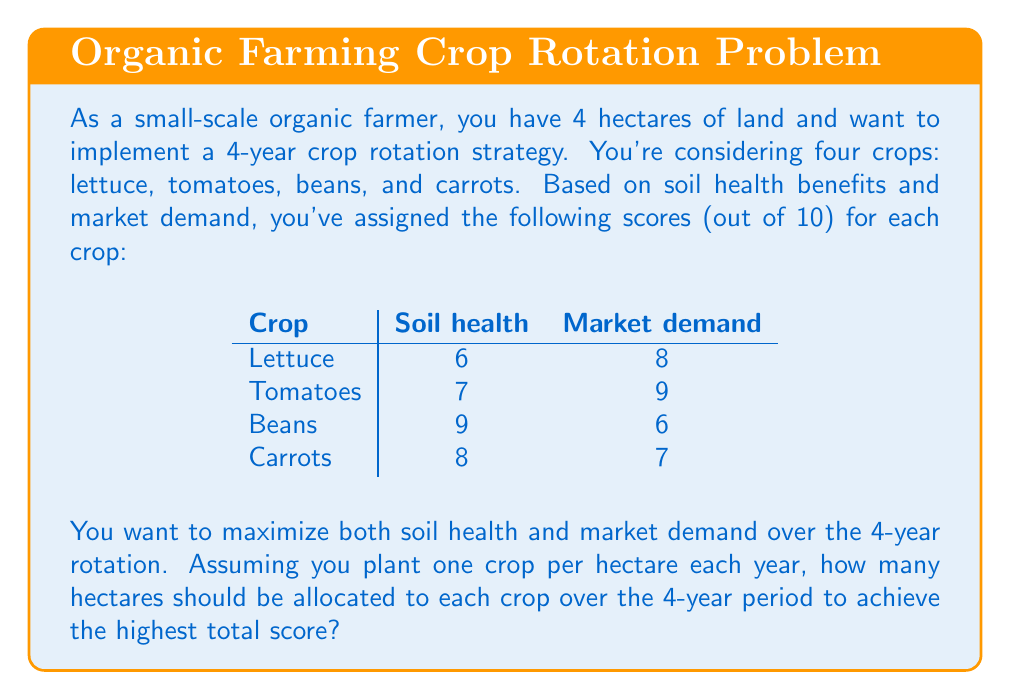Teach me how to tackle this problem. To solve this problem, we need to use integer programming, a branch of decision theory. Let's approach this step-by-step:

1) Define variables:
   Let $x_1, x_2, x_3, x_4$ represent the number of hectares allocated to lettuce, tomatoes, beans, and carrots respectively over the 4-year period.

2) Set up the objective function:
   We want to maximize the total score, which is the sum of soil health and market demand scores for each crop, multiplied by the number of hectares allocated to that crop:

   $$\text{Max } Z = (6+8)x_1 + (7+9)x_2 + (9+6)x_3 + (8+7)x_4$$
   $$\text{Max } Z = 14x_1 + 16x_2 + 15x_3 + 15x_4$$

3) Define constraints:
   a) The total area used must equal 16 hectare-years (4 hectares * 4 years):
      $$x_1 + x_2 + x_3 + x_4 = 16$$
   
   b) Each variable must be a non-negative integer:
      $$x_1, x_2, x_3, x_4 \geq 0 \text{ and integer}$$

4) Solve the integer programming problem:
   The optimal solution is:
   $$x_1 = 0, x_2 = 8, x_3 = 4, x_4 = 4$$

5) Interpret the results:
   Over the 4-year period:
   - 0 hectares should be allocated to lettuce
   - 8 hectares should be allocated to tomatoes
   - 4 hectares should be allocated to beans
   - 4 hectares should be allocated to carrots

   This can be implemented as:
   Year 1: 2 ha tomatoes, 1 ha beans, 1 ha carrots
   Year 2: 2 ha tomatoes, 1 ha beans, 1 ha carrots
   Year 3: 2 ha tomatoes, 1 ha beans, 1 ha carrots
   Year 4: 2 ha tomatoes, 1 ha beans, 1 ha carrots

   The total score achieved is: 16(8) + 15(4) + 15(4) = 248
Answer: Optimal allocation over 4 years:
Lettuce: 0 hectares
Tomatoes: 8 hectares
Beans: 4 hectares
Carrots: 4 hectares 